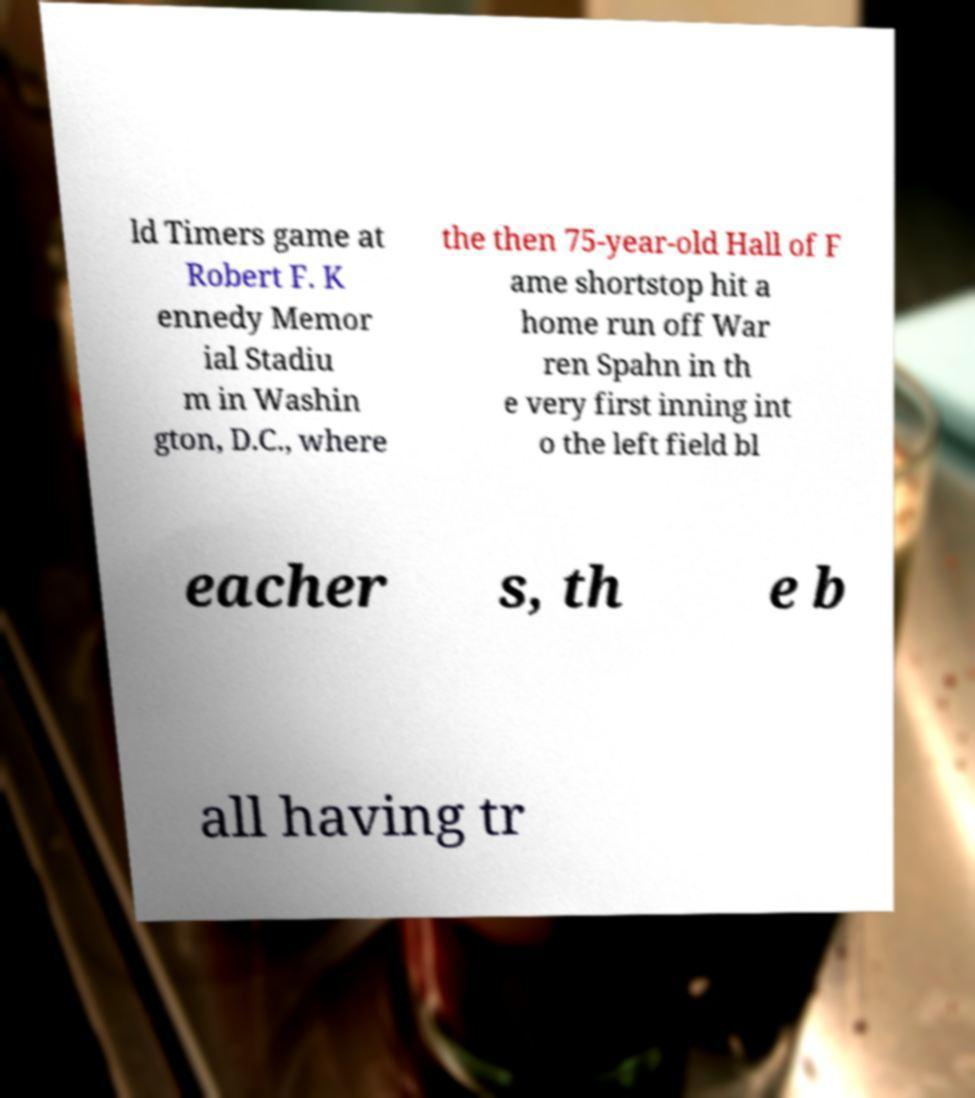Please read and relay the text visible in this image. What does it say? ld Timers game at Robert F. K ennedy Memor ial Stadiu m in Washin gton, D.C., where the then 75-year-old Hall of F ame shortstop hit a home run off War ren Spahn in th e very first inning int o the left field bl eacher s, th e b all having tr 